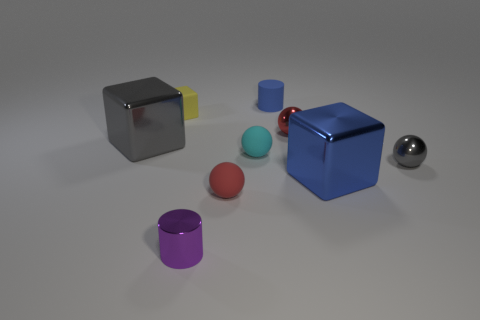There is a gray thing that is the same shape as the yellow object; what material is it? The gray object that has the same cubic shape as the yellow object appears to be made of metal, judging by its reflective surface and sheen that is characteristic of metallic materials. 